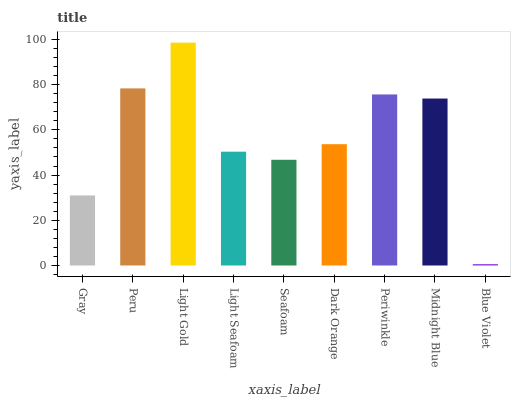Is Blue Violet the minimum?
Answer yes or no. Yes. Is Light Gold the maximum?
Answer yes or no. Yes. Is Peru the minimum?
Answer yes or no. No. Is Peru the maximum?
Answer yes or no. No. Is Peru greater than Gray?
Answer yes or no. Yes. Is Gray less than Peru?
Answer yes or no. Yes. Is Gray greater than Peru?
Answer yes or no. No. Is Peru less than Gray?
Answer yes or no. No. Is Dark Orange the high median?
Answer yes or no. Yes. Is Dark Orange the low median?
Answer yes or no. Yes. Is Periwinkle the high median?
Answer yes or no. No. Is Light Seafoam the low median?
Answer yes or no. No. 